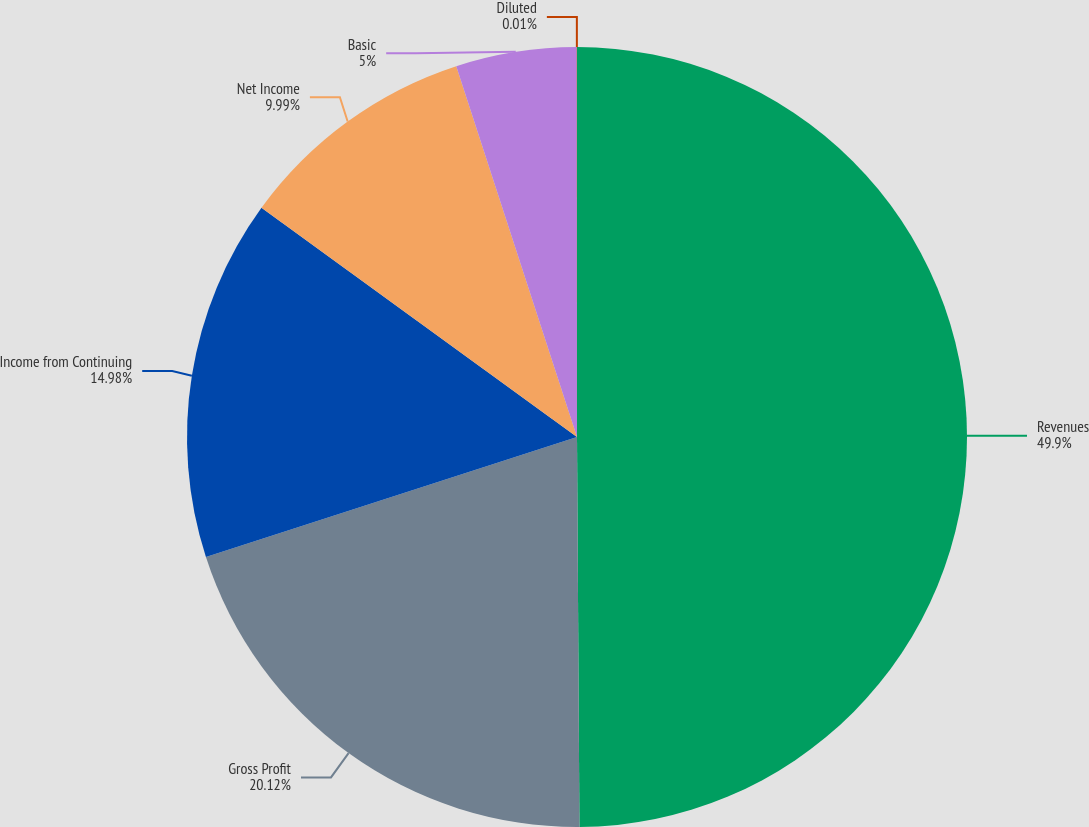Convert chart to OTSL. <chart><loc_0><loc_0><loc_500><loc_500><pie_chart><fcel>Revenues<fcel>Gross Profit<fcel>Income from Continuing<fcel>Net Income<fcel>Basic<fcel>Diluted<nl><fcel>49.9%<fcel>20.12%<fcel>14.98%<fcel>9.99%<fcel>5.0%<fcel>0.01%<nl></chart> 